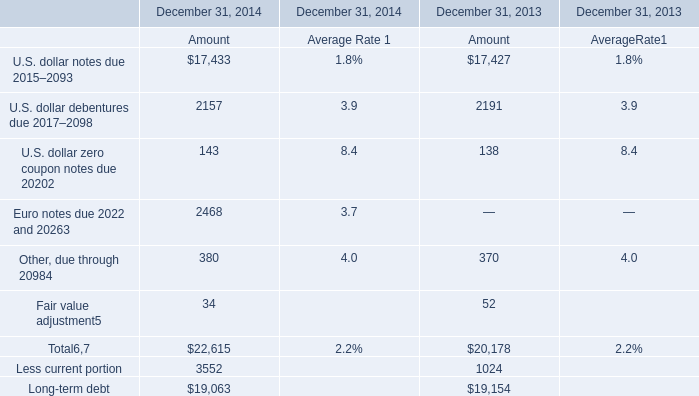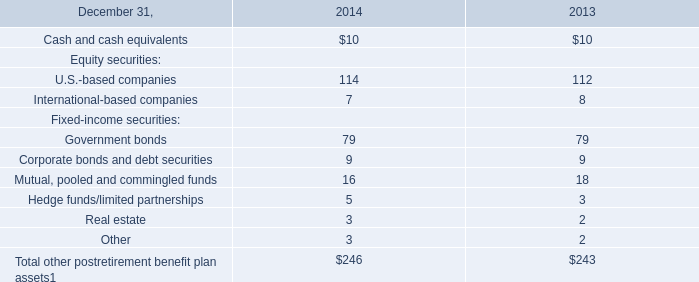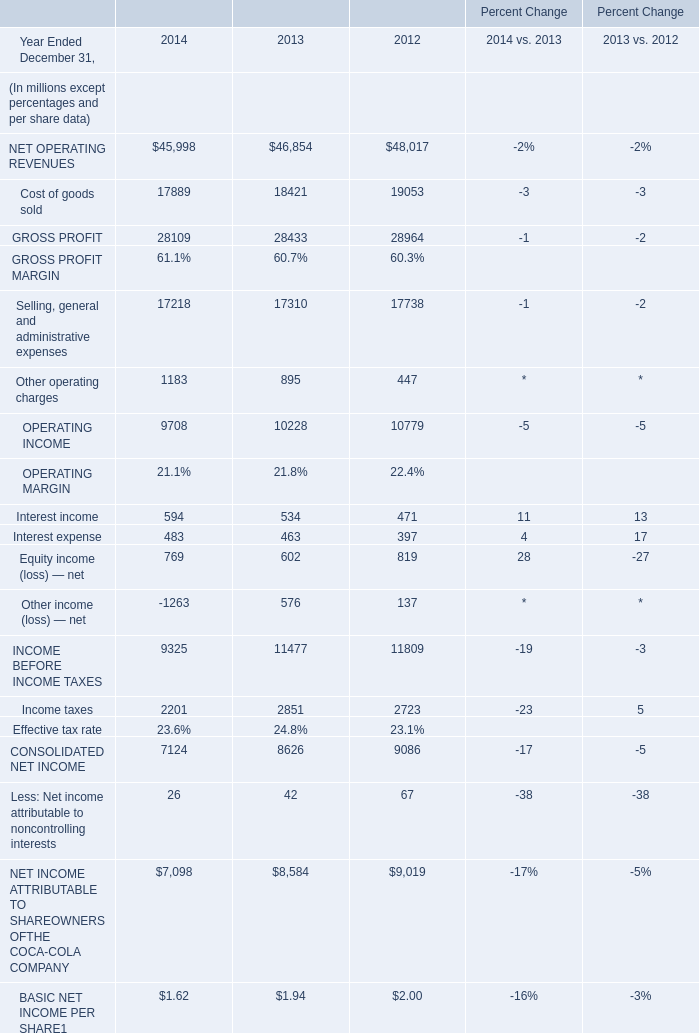What is the sum of Cost of goods sold of Percent Change 2014, and U.S. dollar debentures due 2017–2098 of December 31, 2014 Amount ? 
Computations: (17889.0 + 2157.0)
Answer: 20046.0. 